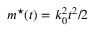<formula> <loc_0><loc_0><loc_500><loc_500>m ^ { ^ { * } } ( t ) = k _ { 0 } ^ { 2 } t ^ { 2 } / 2</formula> 